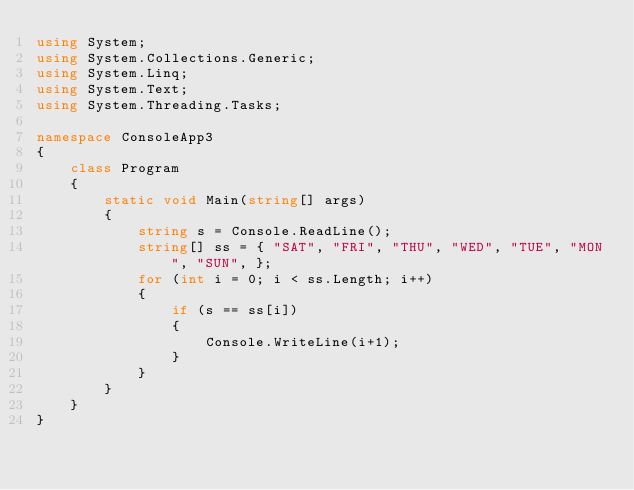Convert code to text. <code><loc_0><loc_0><loc_500><loc_500><_C#_>using System;
using System.Collections.Generic;
using System.Linq;
using System.Text;
using System.Threading.Tasks;

namespace ConsoleApp3
{
    class Program
    {
        static void Main(string[] args)
        {
            string s = Console.ReadLine();
            string[] ss = { "SAT", "FRI", "THU", "WED", "TUE", "MON", "SUN", };
            for (int i = 0; i < ss.Length; i++)
            {
                if (s == ss[i])
                {
                    Console.WriteLine(i+1);
                }
            }
        }
    }
}
</code> 